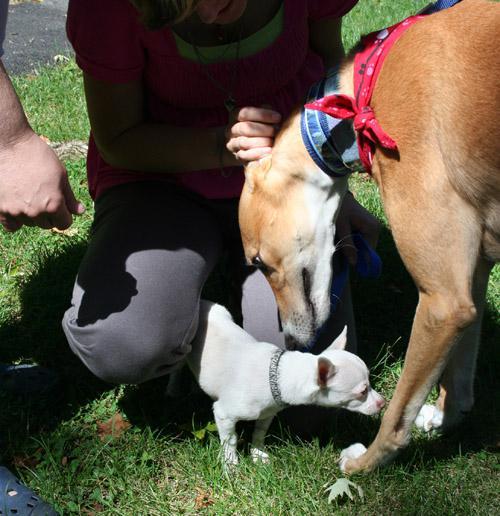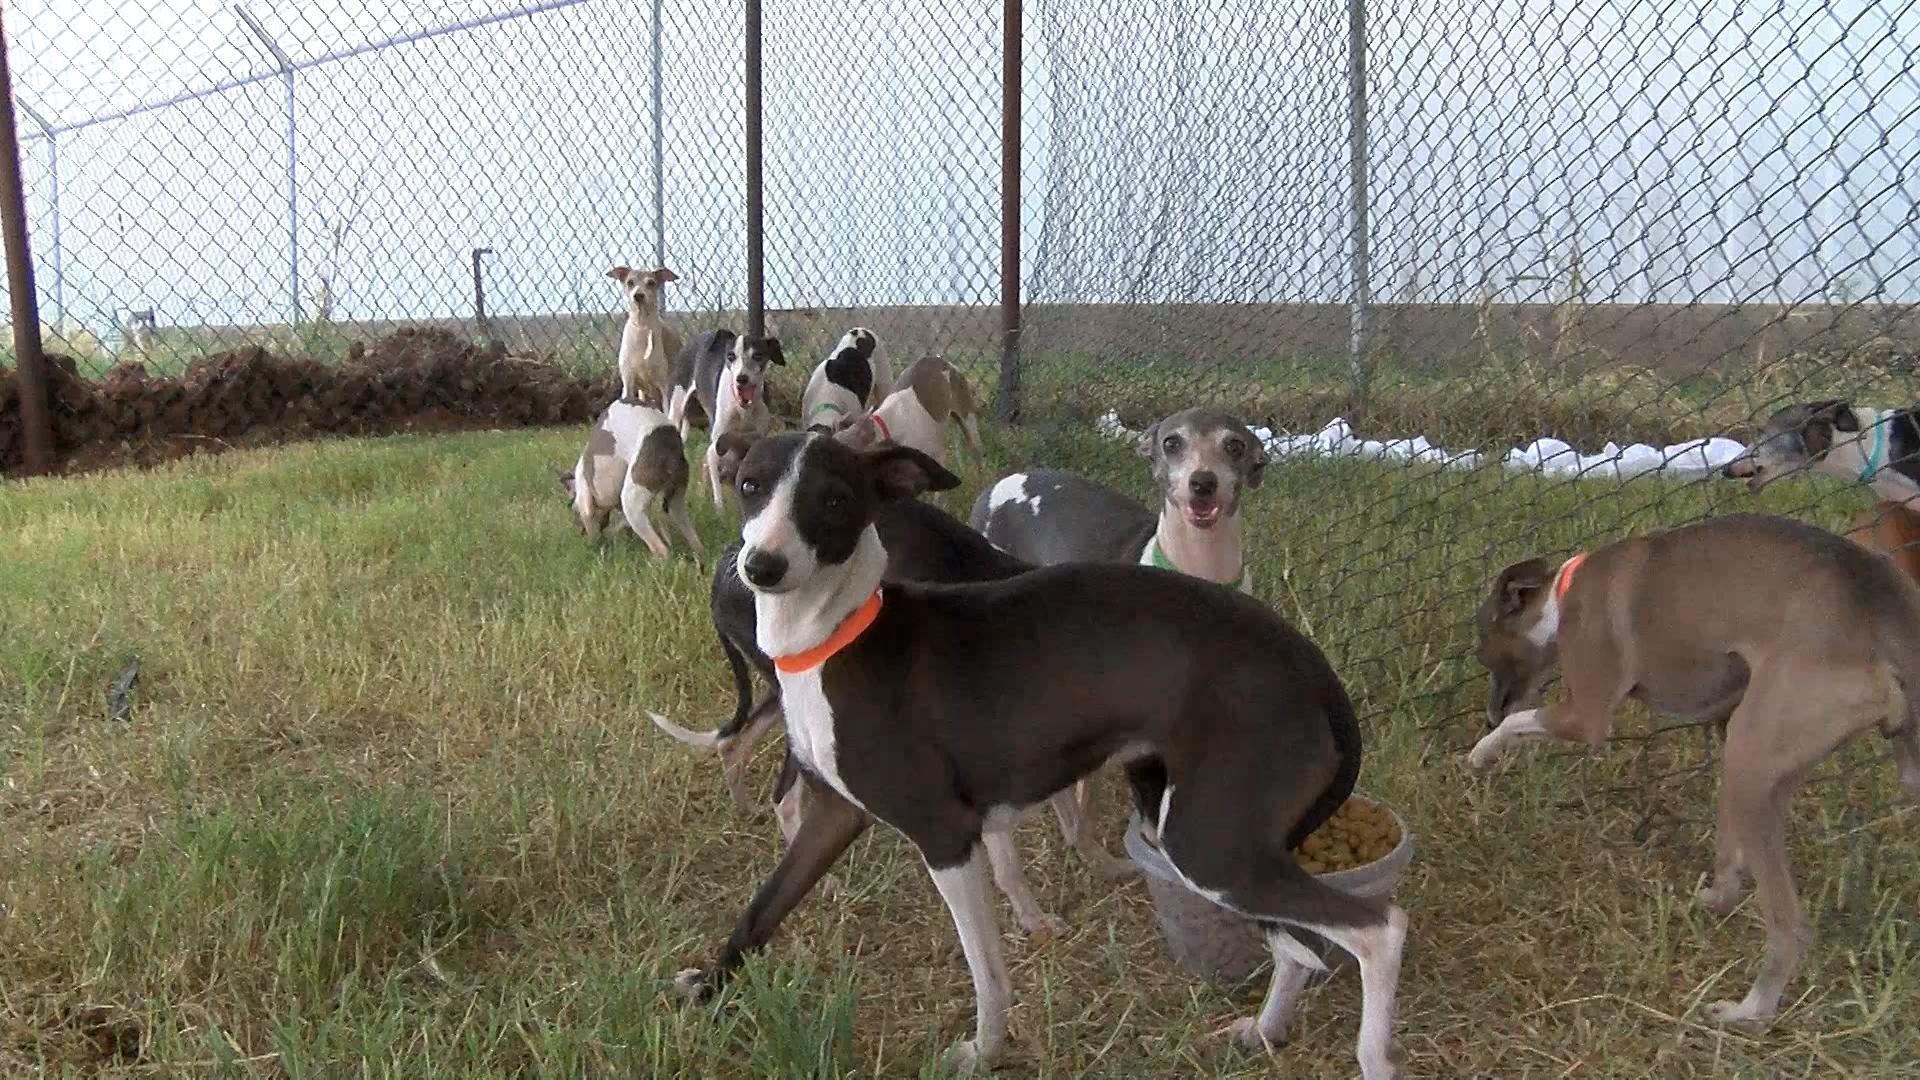The first image is the image on the left, the second image is the image on the right. For the images shown, is this caption "A person is with at least one dog in the grass in one of the pictures." true? Answer yes or no. Yes. The first image is the image on the left, the second image is the image on the right. Given the left and right images, does the statement "An image shows a human hand touching the head of a hound wearing a bandana." hold true? Answer yes or no. Yes. 